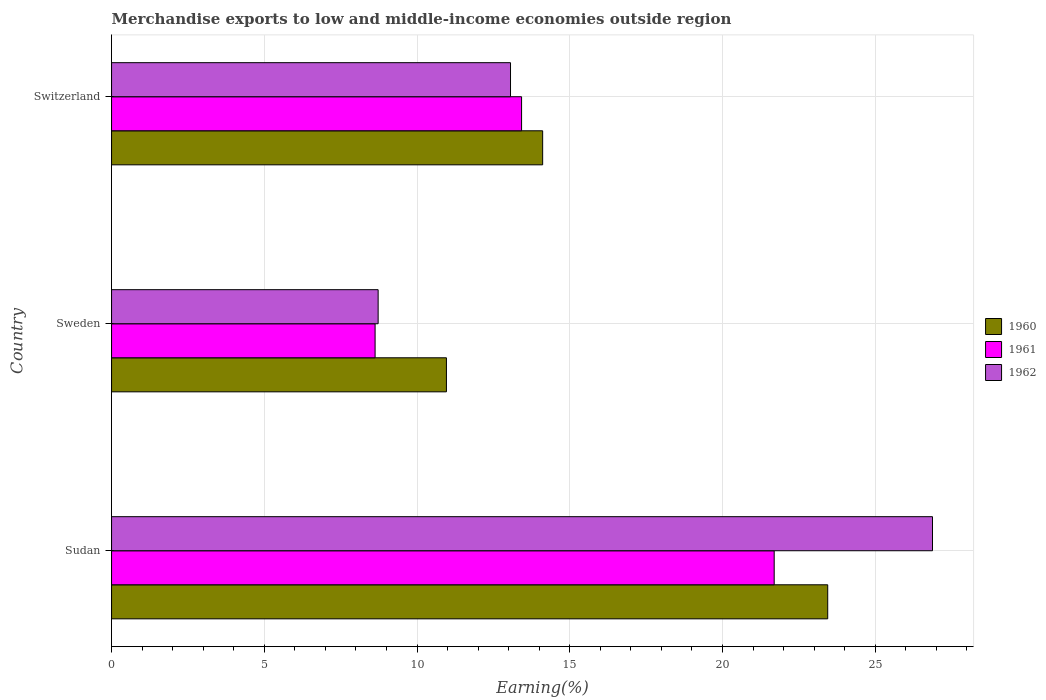How many groups of bars are there?
Your response must be concise. 3. Are the number of bars per tick equal to the number of legend labels?
Provide a succinct answer. Yes. How many bars are there on the 1st tick from the bottom?
Ensure brevity in your answer.  3. What is the label of the 1st group of bars from the top?
Your answer should be compact. Switzerland. What is the percentage of amount earned from merchandise exports in 1960 in Sudan?
Make the answer very short. 23.45. Across all countries, what is the maximum percentage of amount earned from merchandise exports in 1960?
Your answer should be very brief. 23.45. Across all countries, what is the minimum percentage of amount earned from merchandise exports in 1962?
Your answer should be very brief. 8.73. In which country was the percentage of amount earned from merchandise exports in 1961 maximum?
Offer a very short reply. Sudan. What is the total percentage of amount earned from merchandise exports in 1960 in the graph?
Make the answer very short. 48.52. What is the difference between the percentage of amount earned from merchandise exports in 1961 in Sudan and that in Switzerland?
Ensure brevity in your answer.  8.27. What is the difference between the percentage of amount earned from merchandise exports in 1962 in Sudan and the percentage of amount earned from merchandise exports in 1961 in Switzerland?
Your response must be concise. 13.45. What is the average percentage of amount earned from merchandise exports in 1960 per country?
Make the answer very short. 16.17. What is the difference between the percentage of amount earned from merchandise exports in 1961 and percentage of amount earned from merchandise exports in 1962 in Sudan?
Keep it short and to the point. -5.18. What is the ratio of the percentage of amount earned from merchandise exports in 1962 in Sudan to that in Sweden?
Offer a very short reply. 3.08. Is the percentage of amount earned from merchandise exports in 1961 in Sudan less than that in Sweden?
Your response must be concise. No. Is the difference between the percentage of amount earned from merchandise exports in 1961 in Sudan and Switzerland greater than the difference between the percentage of amount earned from merchandise exports in 1962 in Sudan and Switzerland?
Offer a very short reply. No. What is the difference between the highest and the second highest percentage of amount earned from merchandise exports in 1960?
Your answer should be compact. 9.33. What is the difference between the highest and the lowest percentage of amount earned from merchandise exports in 1962?
Give a very brief answer. 18.15. In how many countries, is the percentage of amount earned from merchandise exports in 1962 greater than the average percentage of amount earned from merchandise exports in 1962 taken over all countries?
Provide a succinct answer. 1. What does the 2nd bar from the bottom in Switzerland represents?
Provide a short and direct response. 1961. How many bars are there?
Your response must be concise. 9. Are all the bars in the graph horizontal?
Provide a short and direct response. Yes. Are the values on the major ticks of X-axis written in scientific E-notation?
Offer a terse response. No. Does the graph contain any zero values?
Your response must be concise. No. Does the graph contain grids?
Keep it short and to the point. Yes. What is the title of the graph?
Offer a terse response. Merchandise exports to low and middle-income economies outside region. What is the label or title of the X-axis?
Provide a short and direct response. Earning(%). What is the label or title of the Y-axis?
Give a very brief answer. Country. What is the Earning(%) of 1960 in Sudan?
Your response must be concise. 23.45. What is the Earning(%) in 1961 in Sudan?
Your answer should be compact. 21.69. What is the Earning(%) of 1962 in Sudan?
Your answer should be compact. 26.88. What is the Earning(%) in 1960 in Sweden?
Offer a terse response. 10.96. What is the Earning(%) in 1961 in Sweden?
Keep it short and to the point. 8.63. What is the Earning(%) in 1962 in Sweden?
Provide a short and direct response. 8.73. What is the Earning(%) in 1960 in Switzerland?
Offer a very short reply. 14.11. What is the Earning(%) in 1961 in Switzerland?
Give a very brief answer. 13.42. What is the Earning(%) in 1962 in Switzerland?
Give a very brief answer. 13.06. Across all countries, what is the maximum Earning(%) of 1960?
Make the answer very short. 23.45. Across all countries, what is the maximum Earning(%) of 1961?
Make the answer very short. 21.69. Across all countries, what is the maximum Earning(%) in 1962?
Give a very brief answer. 26.88. Across all countries, what is the minimum Earning(%) of 1960?
Give a very brief answer. 10.96. Across all countries, what is the minimum Earning(%) in 1961?
Ensure brevity in your answer.  8.63. Across all countries, what is the minimum Earning(%) of 1962?
Give a very brief answer. 8.73. What is the total Earning(%) of 1960 in the graph?
Provide a short and direct response. 48.52. What is the total Earning(%) of 1961 in the graph?
Your response must be concise. 43.74. What is the total Earning(%) of 1962 in the graph?
Offer a terse response. 48.66. What is the difference between the Earning(%) of 1960 in Sudan and that in Sweden?
Give a very brief answer. 12.48. What is the difference between the Earning(%) of 1961 in Sudan and that in Sweden?
Keep it short and to the point. 13.07. What is the difference between the Earning(%) of 1962 in Sudan and that in Sweden?
Offer a very short reply. 18.15. What is the difference between the Earning(%) of 1960 in Sudan and that in Switzerland?
Ensure brevity in your answer.  9.33. What is the difference between the Earning(%) in 1961 in Sudan and that in Switzerland?
Keep it short and to the point. 8.27. What is the difference between the Earning(%) in 1962 in Sudan and that in Switzerland?
Offer a terse response. 13.81. What is the difference between the Earning(%) in 1960 in Sweden and that in Switzerland?
Make the answer very short. -3.15. What is the difference between the Earning(%) in 1961 in Sweden and that in Switzerland?
Give a very brief answer. -4.8. What is the difference between the Earning(%) in 1962 in Sweden and that in Switzerland?
Your response must be concise. -4.33. What is the difference between the Earning(%) of 1960 in Sudan and the Earning(%) of 1961 in Sweden?
Keep it short and to the point. 14.82. What is the difference between the Earning(%) in 1960 in Sudan and the Earning(%) in 1962 in Sweden?
Make the answer very short. 14.72. What is the difference between the Earning(%) in 1961 in Sudan and the Earning(%) in 1962 in Sweden?
Provide a succinct answer. 12.97. What is the difference between the Earning(%) of 1960 in Sudan and the Earning(%) of 1961 in Switzerland?
Your answer should be very brief. 10.02. What is the difference between the Earning(%) in 1960 in Sudan and the Earning(%) in 1962 in Switzerland?
Ensure brevity in your answer.  10.38. What is the difference between the Earning(%) of 1961 in Sudan and the Earning(%) of 1962 in Switzerland?
Offer a very short reply. 8.63. What is the difference between the Earning(%) in 1960 in Sweden and the Earning(%) in 1961 in Switzerland?
Your answer should be compact. -2.46. What is the difference between the Earning(%) in 1960 in Sweden and the Earning(%) in 1962 in Switzerland?
Keep it short and to the point. -2.1. What is the difference between the Earning(%) in 1961 in Sweden and the Earning(%) in 1962 in Switzerland?
Ensure brevity in your answer.  -4.43. What is the average Earning(%) in 1960 per country?
Make the answer very short. 16.17. What is the average Earning(%) in 1961 per country?
Your answer should be very brief. 14.58. What is the average Earning(%) in 1962 per country?
Your response must be concise. 16.22. What is the difference between the Earning(%) of 1960 and Earning(%) of 1961 in Sudan?
Provide a short and direct response. 1.75. What is the difference between the Earning(%) of 1960 and Earning(%) of 1962 in Sudan?
Keep it short and to the point. -3.43. What is the difference between the Earning(%) in 1961 and Earning(%) in 1962 in Sudan?
Make the answer very short. -5.18. What is the difference between the Earning(%) in 1960 and Earning(%) in 1961 in Sweden?
Your answer should be compact. 2.34. What is the difference between the Earning(%) of 1960 and Earning(%) of 1962 in Sweden?
Provide a short and direct response. 2.24. What is the difference between the Earning(%) of 1961 and Earning(%) of 1962 in Sweden?
Ensure brevity in your answer.  -0.1. What is the difference between the Earning(%) in 1960 and Earning(%) in 1961 in Switzerland?
Provide a succinct answer. 0.69. What is the difference between the Earning(%) in 1960 and Earning(%) in 1962 in Switzerland?
Your answer should be very brief. 1.05. What is the difference between the Earning(%) of 1961 and Earning(%) of 1962 in Switzerland?
Offer a terse response. 0.36. What is the ratio of the Earning(%) of 1960 in Sudan to that in Sweden?
Provide a succinct answer. 2.14. What is the ratio of the Earning(%) of 1961 in Sudan to that in Sweden?
Your answer should be compact. 2.51. What is the ratio of the Earning(%) in 1962 in Sudan to that in Sweden?
Provide a succinct answer. 3.08. What is the ratio of the Earning(%) of 1960 in Sudan to that in Switzerland?
Your answer should be compact. 1.66. What is the ratio of the Earning(%) of 1961 in Sudan to that in Switzerland?
Your answer should be very brief. 1.62. What is the ratio of the Earning(%) in 1962 in Sudan to that in Switzerland?
Your response must be concise. 2.06. What is the ratio of the Earning(%) in 1960 in Sweden to that in Switzerland?
Give a very brief answer. 0.78. What is the ratio of the Earning(%) of 1961 in Sweden to that in Switzerland?
Your answer should be compact. 0.64. What is the ratio of the Earning(%) in 1962 in Sweden to that in Switzerland?
Give a very brief answer. 0.67. What is the difference between the highest and the second highest Earning(%) in 1960?
Your response must be concise. 9.33. What is the difference between the highest and the second highest Earning(%) of 1961?
Ensure brevity in your answer.  8.27. What is the difference between the highest and the second highest Earning(%) in 1962?
Offer a terse response. 13.81. What is the difference between the highest and the lowest Earning(%) in 1960?
Ensure brevity in your answer.  12.48. What is the difference between the highest and the lowest Earning(%) of 1961?
Your answer should be compact. 13.07. What is the difference between the highest and the lowest Earning(%) in 1962?
Provide a short and direct response. 18.15. 